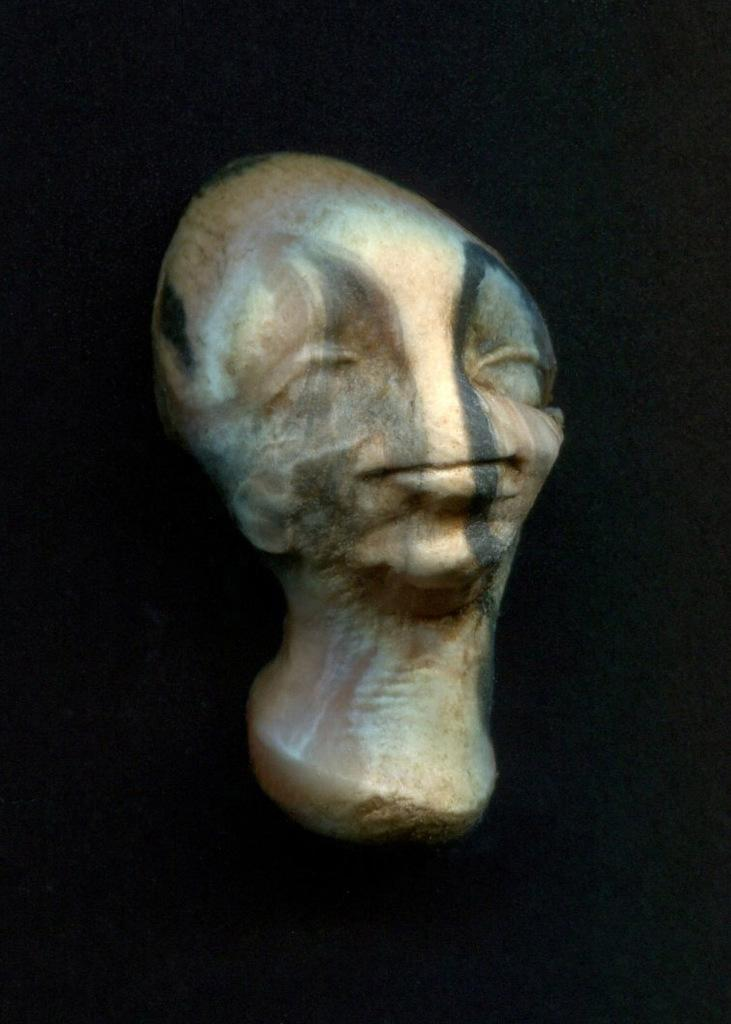What is the main subject of the image? There is a sculpture in the shape of a man's face in the image. What can be observed about the background of the image? The background of the image is dark. What grade does the sculpture receive for its growth in the image? There is no indication of growth or grades in the image, as it features a sculpture and a dark background. 